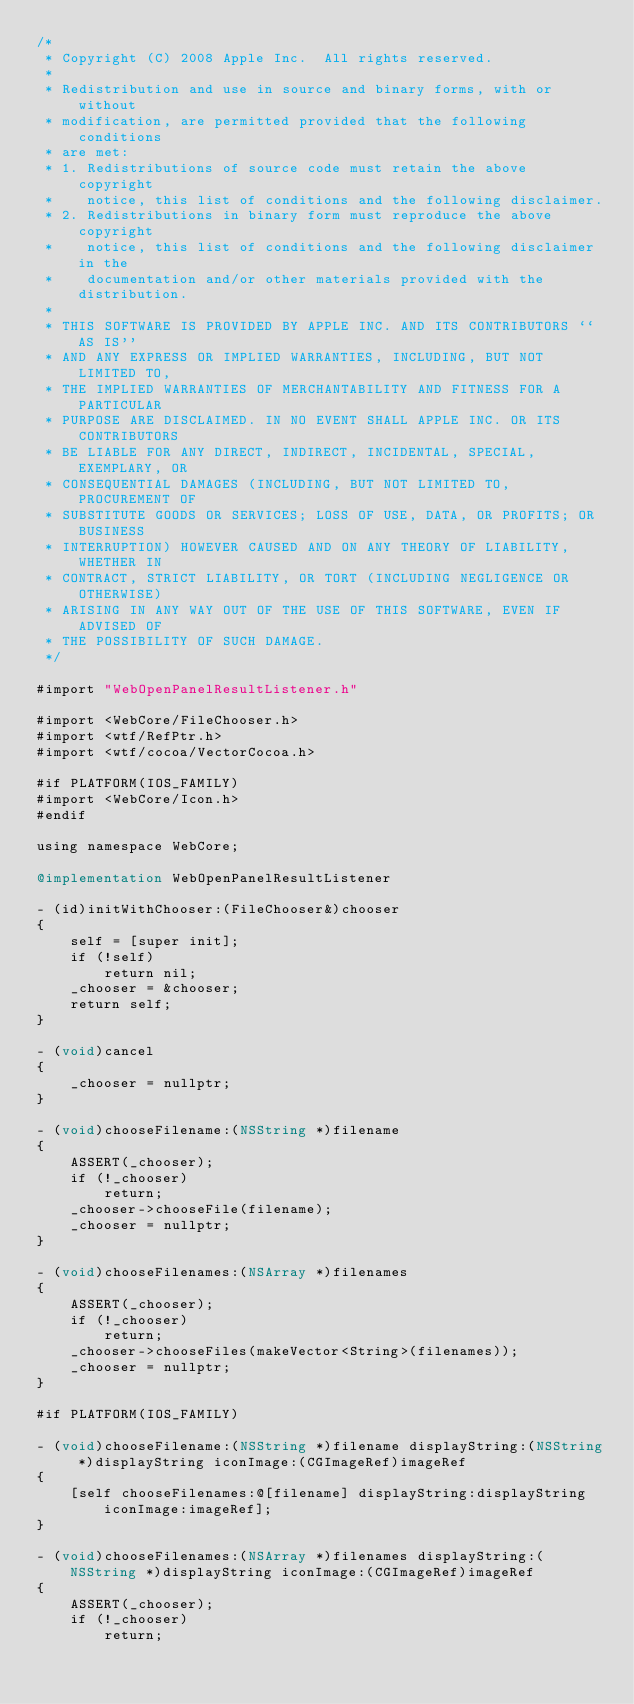<code> <loc_0><loc_0><loc_500><loc_500><_ObjectiveC_>/*
 * Copyright (C) 2008 Apple Inc.  All rights reserved.
 *
 * Redistribution and use in source and binary forms, with or without
 * modification, are permitted provided that the following conditions
 * are met:
 * 1. Redistributions of source code must retain the above copyright
 *    notice, this list of conditions and the following disclaimer.
 * 2. Redistributions in binary form must reproduce the above copyright
 *    notice, this list of conditions and the following disclaimer in the
 *    documentation and/or other materials provided with the distribution.
 *
 * THIS SOFTWARE IS PROVIDED BY APPLE INC. AND ITS CONTRIBUTORS ``AS IS''
 * AND ANY EXPRESS OR IMPLIED WARRANTIES, INCLUDING, BUT NOT LIMITED TO,
 * THE IMPLIED WARRANTIES OF MERCHANTABILITY AND FITNESS FOR A PARTICULAR
 * PURPOSE ARE DISCLAIMED. IN NO EVENT SHALL APPLE INC. OR ITS CONTRIBUTORS
 * BE LIABLE FOR ANY DIRECT, INDIRECT, INCIDENTAL, SPECIAL, EXEMPLARY, OR
 * CONSEQUENTIAL DAMAGES (INCLUDING, BUT NOT LIMITED TO, PROCUREMENT OF
 * SUBSTITUTE GOODS OR SERVICES; LOSS OF USE, DATA, OR PROFITS; OR BUSINESS
 * INTERRUPTION) HOWEVER CAUSED AND ON ANY THEORY OF LIABILITY, WHETHER IN
 * CONTRACT, STRICT LIABILITY, OR TORT (INCLUDING NEGLIGENCE OR OTHERWISE)
 * ARISING IN ANY WAY OUT OF THE USE OF THIS SOFTWARE, EVEN IF ADVISED OF
 * THE POSSIBILITY OF SUCH DAMAGE.
 */

#import "WebOpenPanelResultListener.h"

#import <WebCore/FileChooser.h>
#import <wtf/RefPtr.h>
#import <wtf/cocoa/VectorCocoa.h>

#if PLATFORM(IOS_FAMILY)
#import <WebCore/Icon.h>
#endif

using namespace WebCore;

@implementation WebOpenPanelResultListener

- (id)initWithChooser:(FileChooser&)chooser
{
    self = [super init];
    if (!self)
        return nil;
    _chooser = &chooser;
    return self;
}

- (void)cancel
{
    _chooser = nullptr;
}

- (void)chooseFilename:(NSString *)filename
{
    ASSERT(_chooser);
    if (!_chooser)
        return;
    _chooser->chooseFile(filename);
    _chooser = nullptr;
}

- (void)chooseFilenames:(NSArray *)filenames
{
    ASSERT(_chooser);
    if (!_chooser)
        return;
    _chooser->chooseFiles(makeVector<String>(filenames));
    _chooser = nullptr;
}

#if PLATFORM(IOS_FAMILY)

- (void)chooseFilename:(NSString *)filename displayString:(NSString *)displayString iconImage:(CGImageRef)imageRef
{
    [self chooseFilenames:@[filename] displayString:displayString iconImage:imageRef];
}

- (void)chooseFilenames:(NSArray *)filenames displayString:(NSString *)displayString iconImage:(CGImageRef)imageRef
{
    ASSERT(_chooser);
    if (!_chooser)
        return;
</code> 